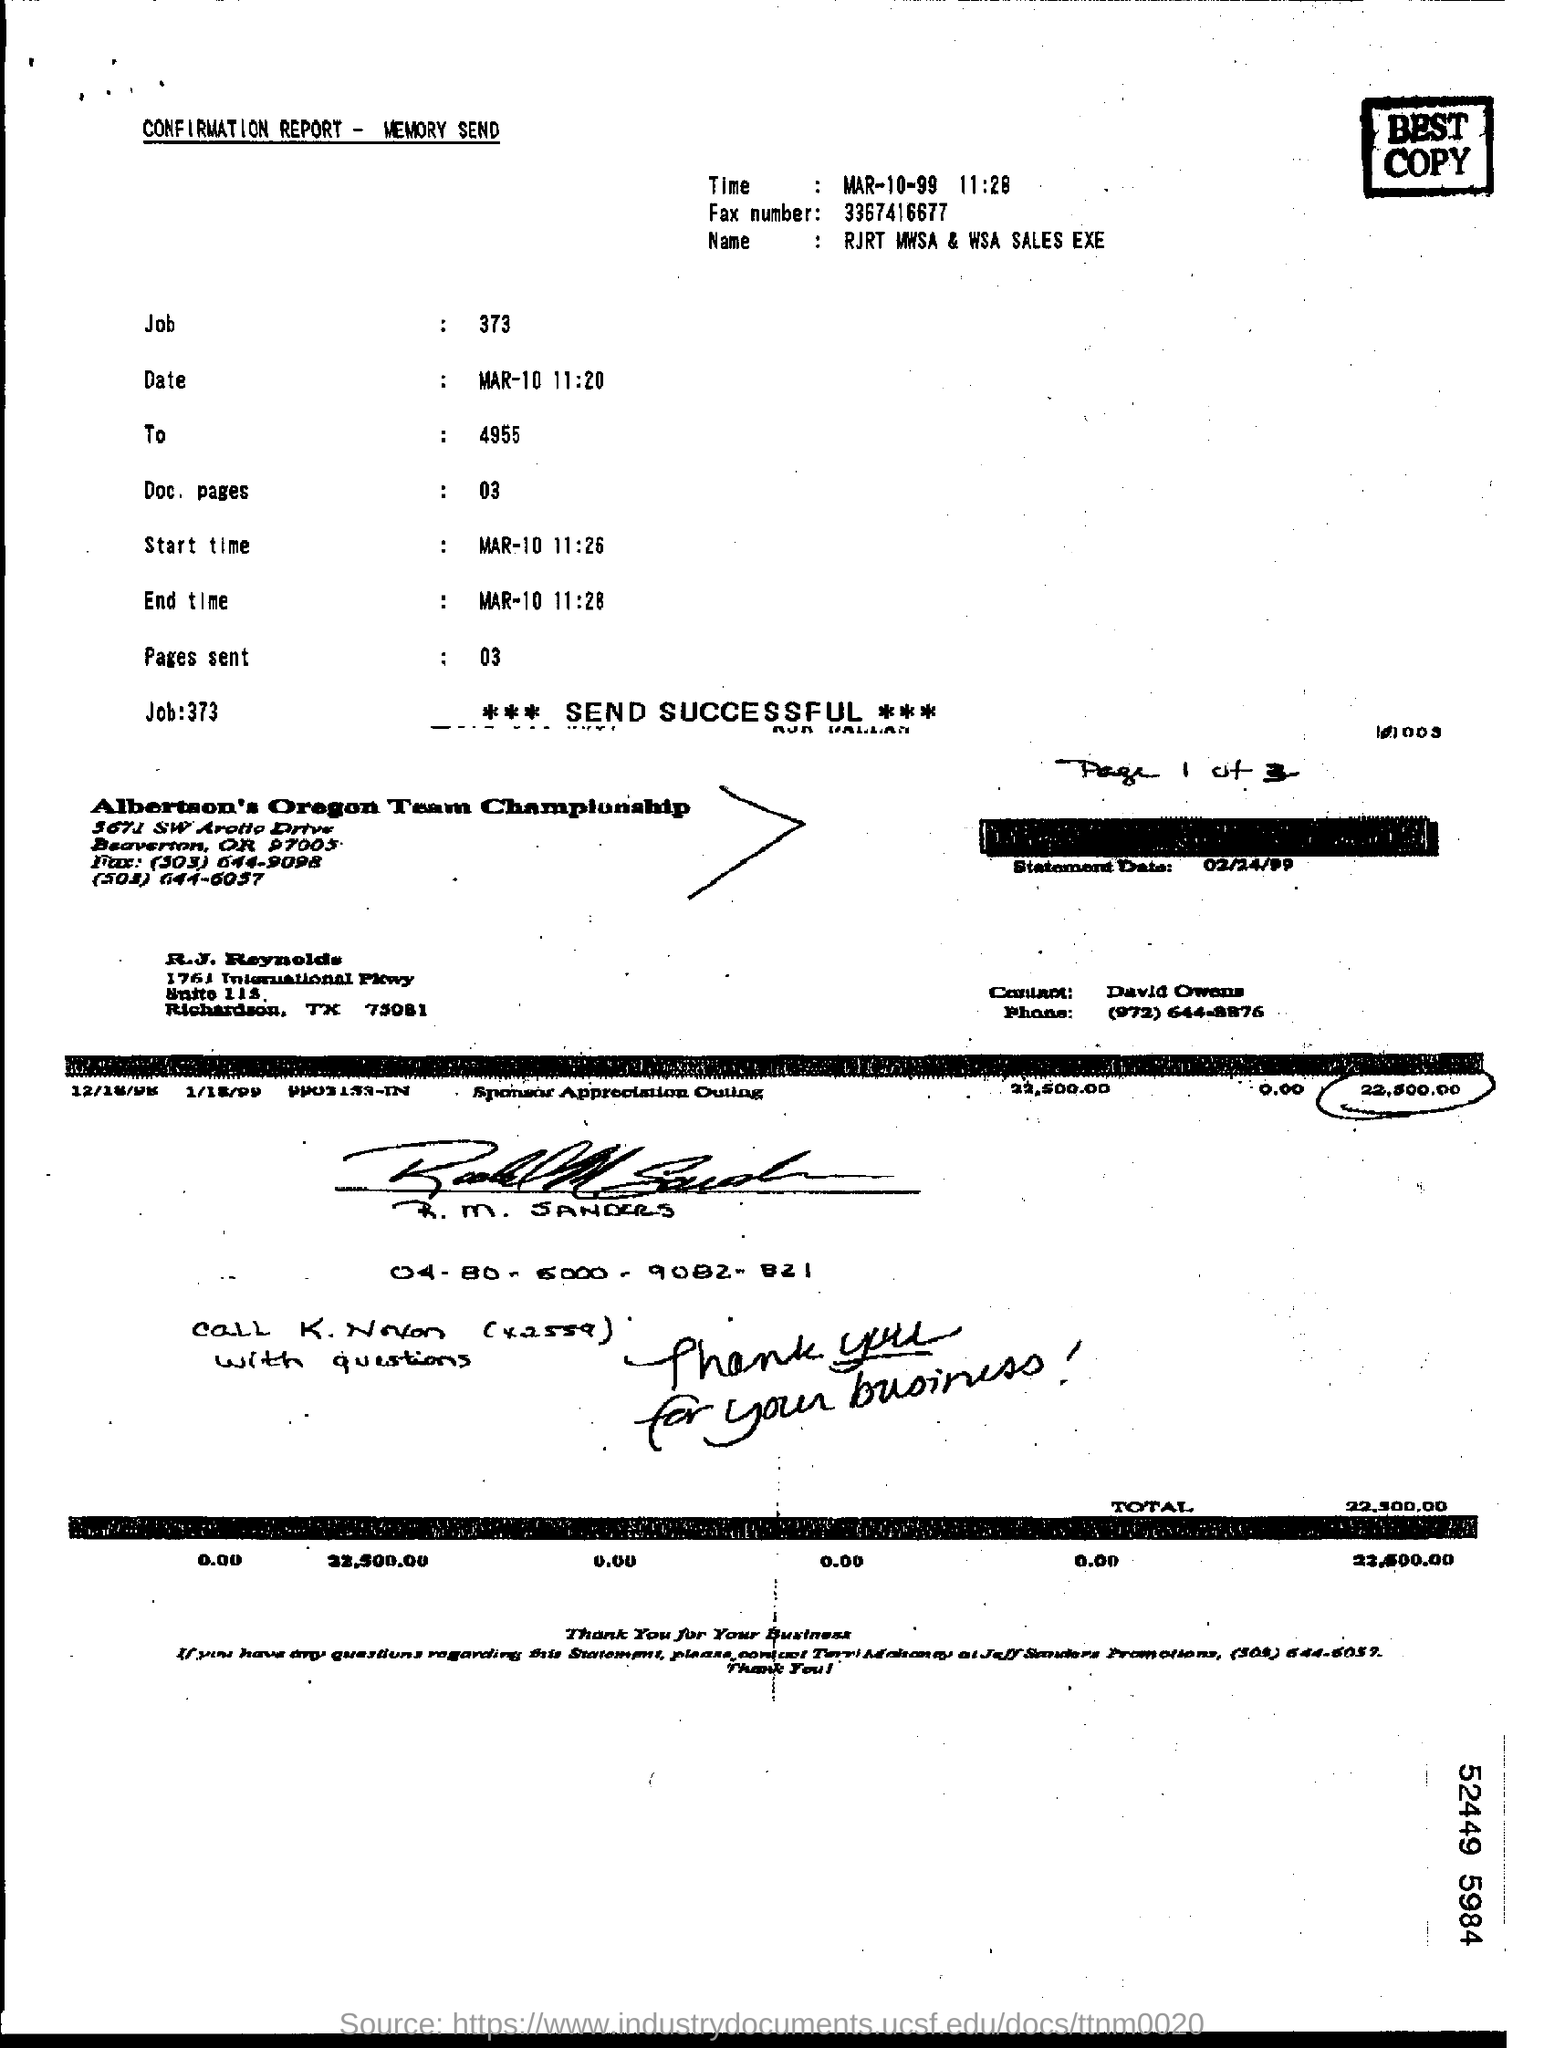Mention a couple of crucial points in this snapshot. The fax number is 3367416677... The name given in the form is "RJRT MWSA & WSA SALES EXE..". The start time is March 10 at 11:26. 